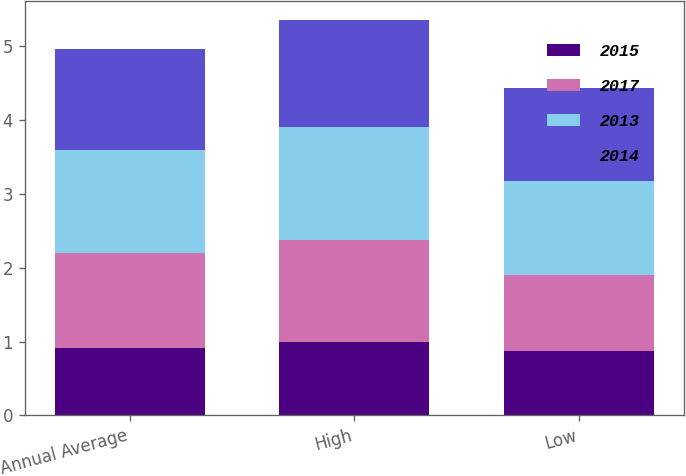<chart> <loc_0><loc_0><loc_500><loc_500><stacked_bar_chart><ecel><fcel>Annual Average<fcel>High<fcel>Low<nl><fcel>2015<fcel>0.91<fcel>0.99<fcel>0.87<nl><fcel>2017<fcel>1.29<fcel>1.38<fcel>1.03<nl><fcel>2013<fcel>1.4<fcel>1.53<fcel>1.28<nl><fcel>2014<fcel>1.36<fcel>1.45<fcel>1.25<nl></chart> 